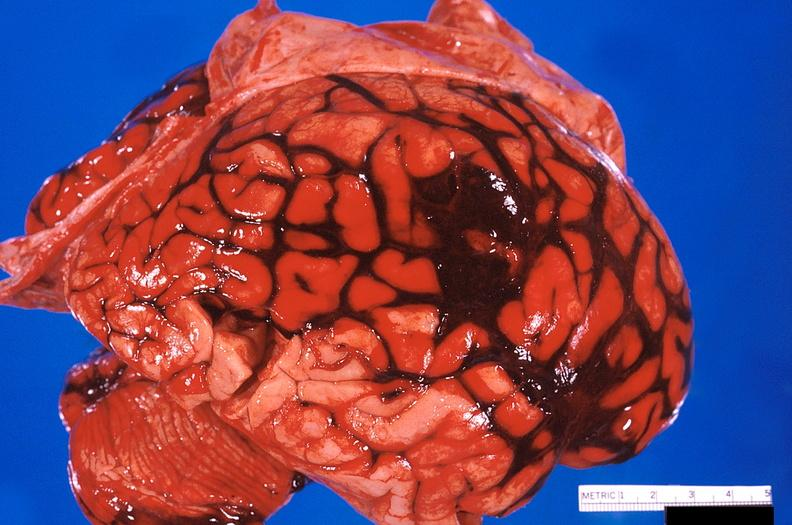why does this image show brain, subarachanoid hemorrhage?
Answer the question using a single word or phrase. Due to ruptured aneurysm 